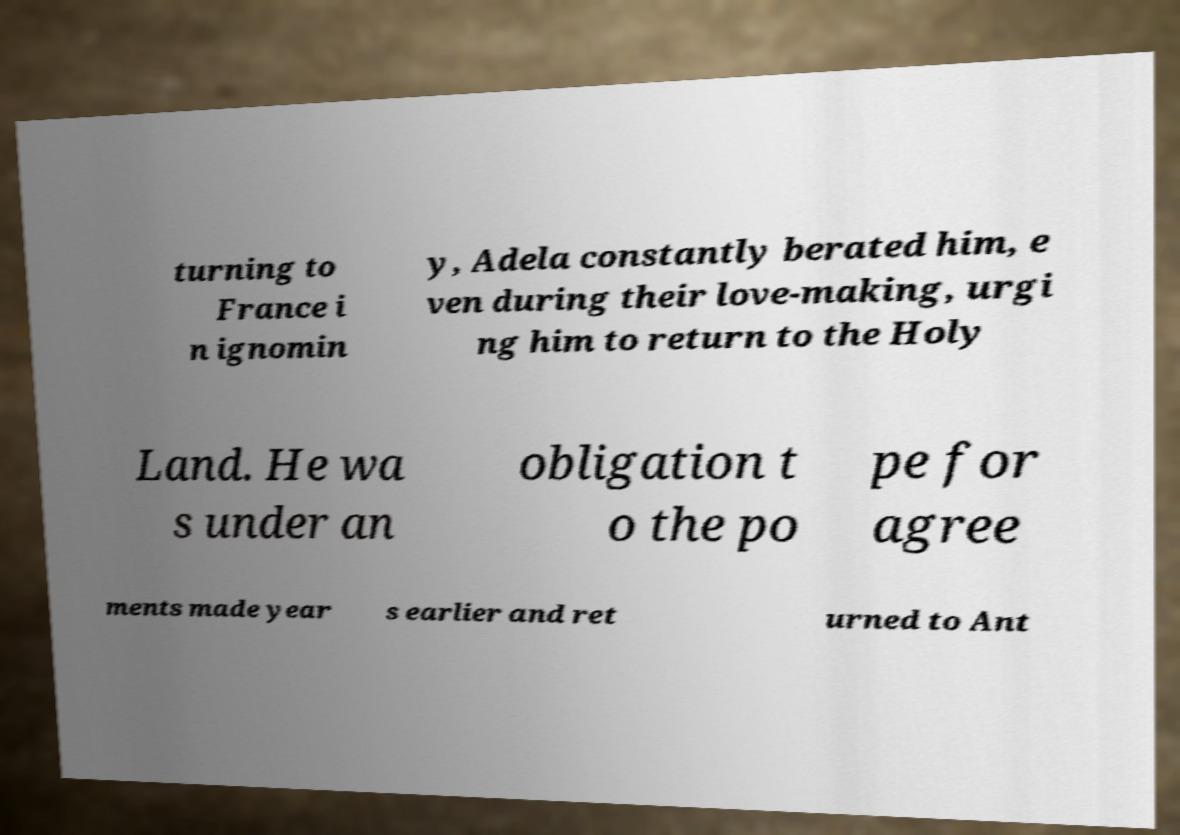I need the written content from this picture converted into text. Can you do that? turning to France i n ignomin y, Adela constantly berated him, e ven during their love-making, urgi ng him to return to the Holy Land. He wa s under an obligation t o the po pe for agree ments made year s earlier and ret urned to Ant 